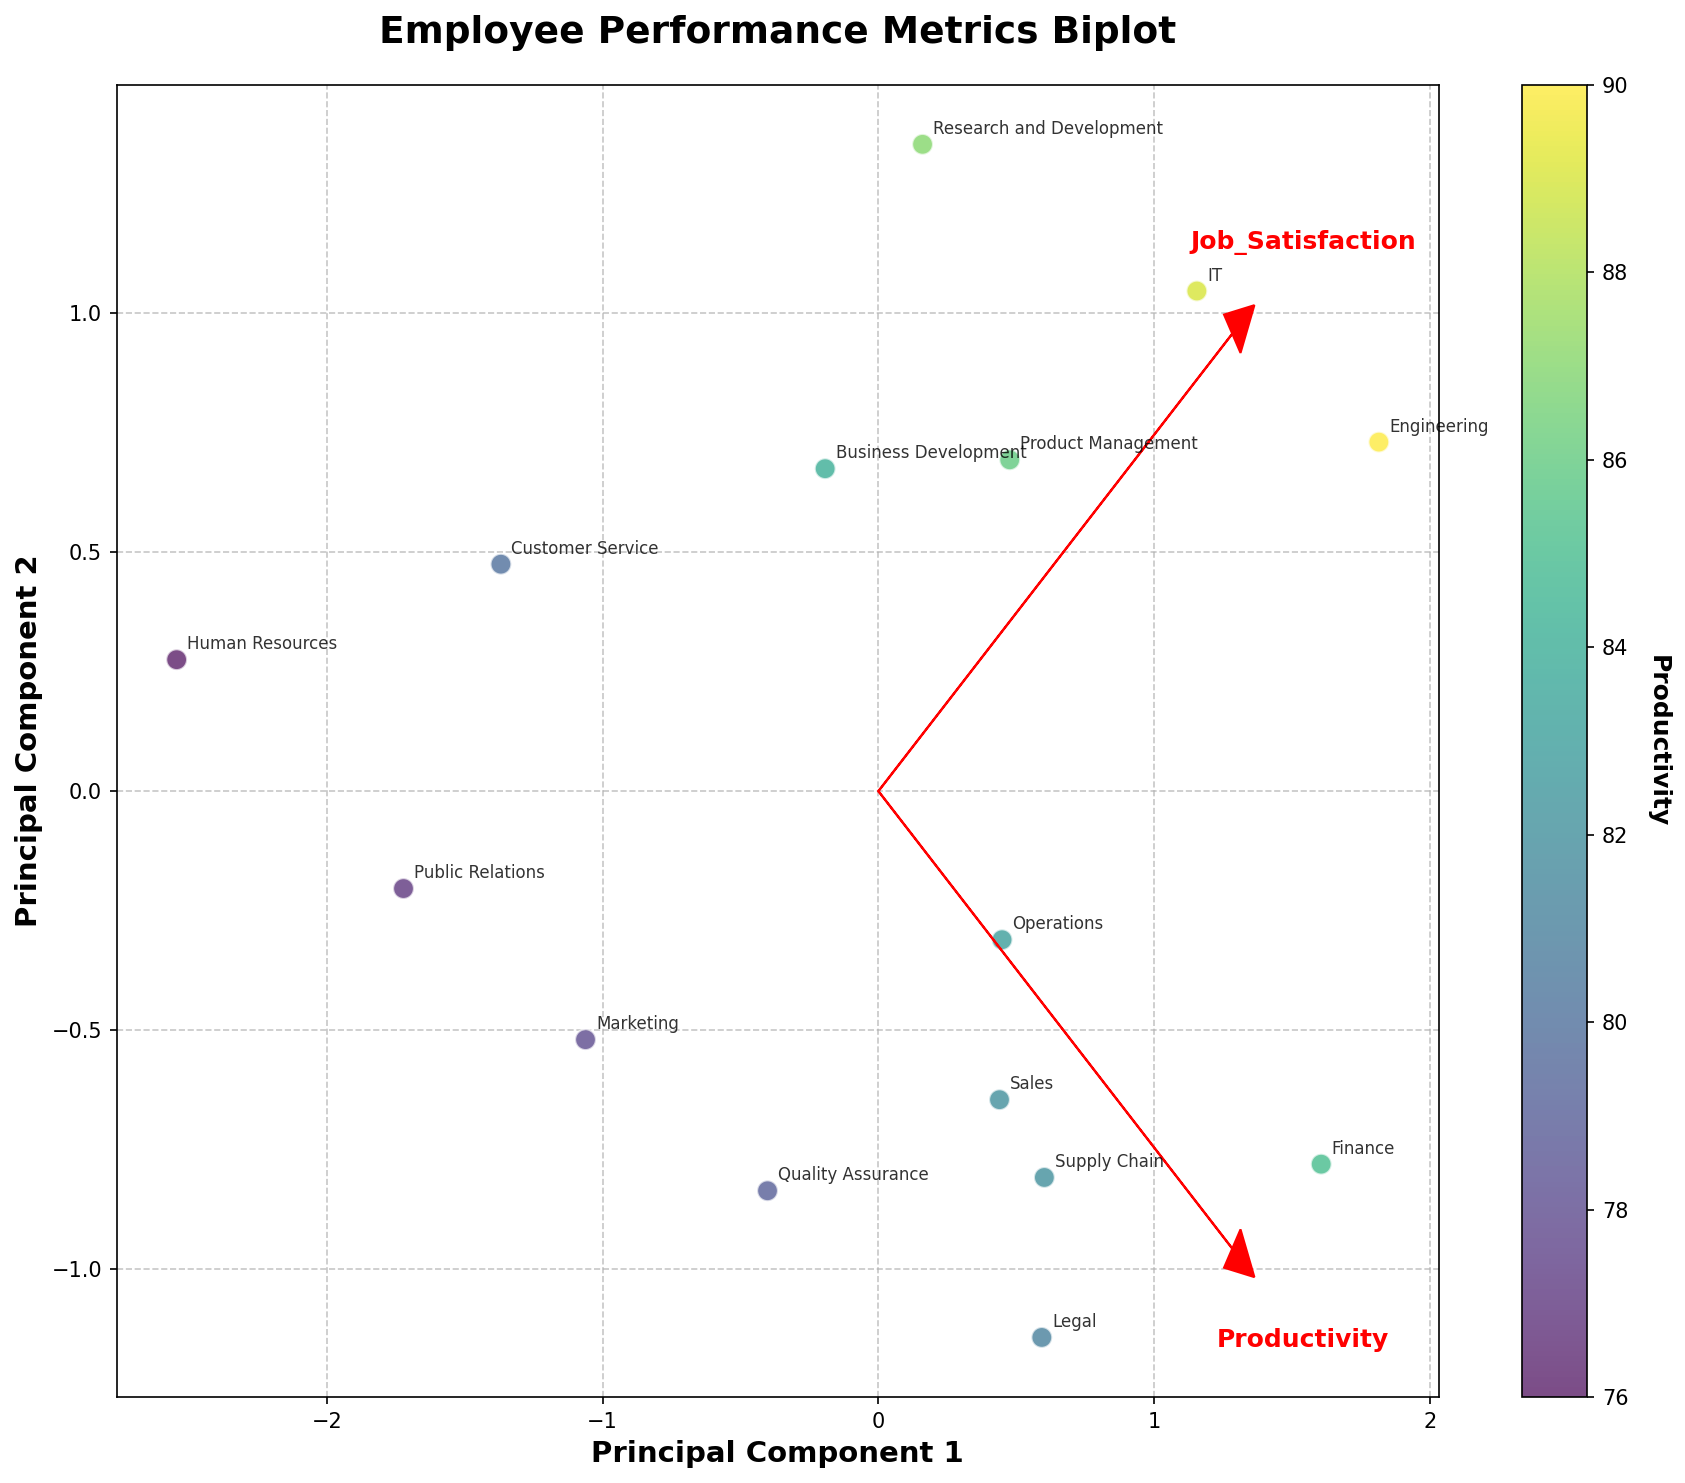What is the title of the figure? The title of the figure is displayed at the top and is clearly labeled. The title helps to quickly understand what the plot is about.
Answer: Employee Performance Metrics Biplot Which department has the highest productivity score? To find the highest productivity score, check the color bar and the respective color of each data point. Identify the department that matches the highest value on the color bar.
Answer: Engineering Which two departments are the closest to each other in terms of their principal component scores? By visually inspecting the scatter plot, identify the data points (represented by the departments) that are nearest to each other in the principal component space.
Answer: Operations and Sales How do Productivity and Job Satisfaction contribute to the two principal components? Look at the red arrows in the plot. Each arrow represents a feature vector. The length and direction of the arrows show the contribution of Productivity and Job Satisfaction to the principal components. Productivity contributes mostly in the direction of Principal Component 1 due to its longer arrow in that direction.
Answer: Productivity contributes more to Principal Component 1, Job Satisfaction contributes to both components significantly What is the primary color gradient used in the plot, and what does it represent? The scatter plot uses a color gradient to indicate the values of productivity. By examining the color bar, we see that it ranges from light to dark colors indicating lower to higher productivity, respectively.
Answer: Viridis, representing Productivity Which department has the lowest job satisfaction score? Refer to the red arrows for Job Satisfaction, then identify the point furthest from the arrow direction within lower regions. Confirm by identifying the respective department label on the plot.
Answer: Finance Compare the Job Satisfaction between Sales and Research and Development departments. By inspecting their positions relative to the Job Satisfaction arrow, it can be seen that the Research and Development department is closer to the higher Job Satisfaction direction than Sales.
Answer: Research and Development has higher Job Satisfaction How many departments fall above the Principal Component 1 axis? Count the number of data points (departments) that are located above the x-axis (Principal Component 1 axis).
Answer: 8 